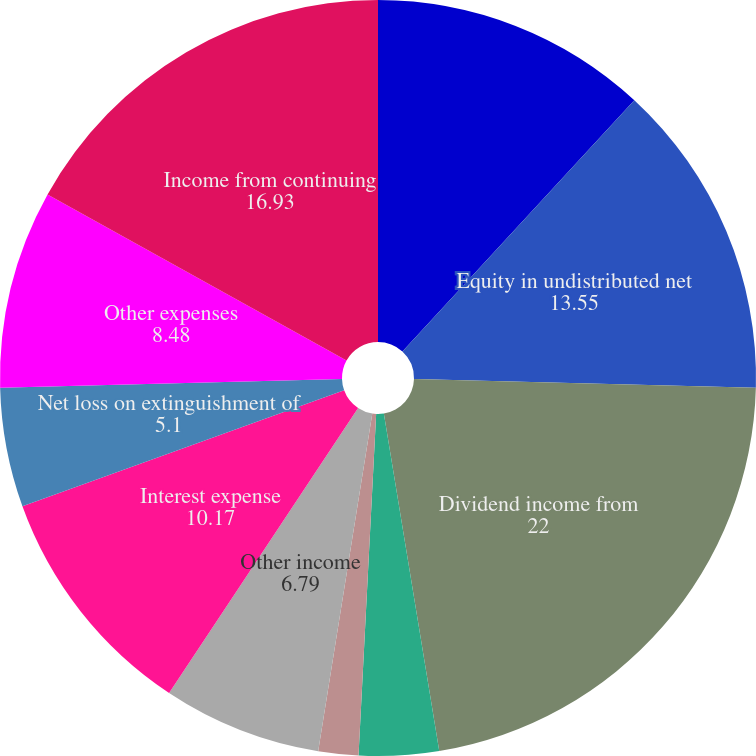<chart> <loc_0><loc_0><loc_500><loc_500><pie_chart><fcel>Years Ended December 31 (in<fcel>Equity in undistributed net<fcel>Dividend income from<fcel>Interest income<fcel>Net realized capital gains<fcel>Other income<fcel>Interest expense<fcel>Net loss on extinguishment of<fcel>Other expenses<fcel>Income from continuing<nl><fcel>11.86%<fcel>13.55%<fcel>22.0%<fcel>3.41%<fcel>1.71%<fcel>6.79%<fcel>10.17%<fcel>5.1%<fcel>8.48%<fcel>16.93%<nl></chart> 